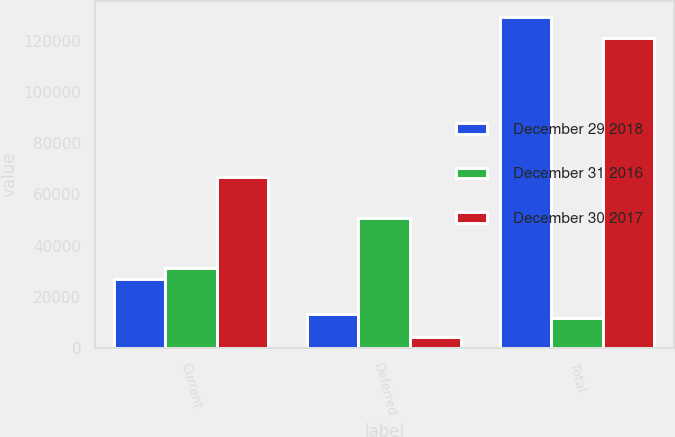Convert chart to OTSL. <chart><loc_0><loc_0><loc_500><loc_500><stacked_bar_chart><ecel><fcel>Current<fcel>Deferred<fcel>Total<nl><fcel>December 29 2018<fcel>26784<fcel>13249<fcel>129167<nl><fcel>December 31 2016<fcel>31343<fcel>50724<fcel>11936<nl><fcel>December 30 2017<fcel>66627<fcel>4522<fcel>120901<nl></chart> 